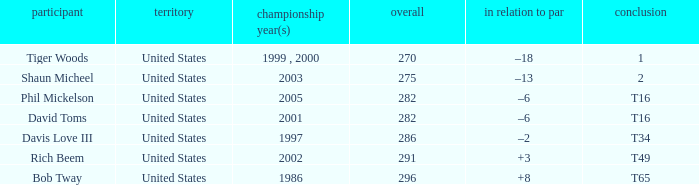In what place did Phil Mickelson finish with a total of 282? T16. 